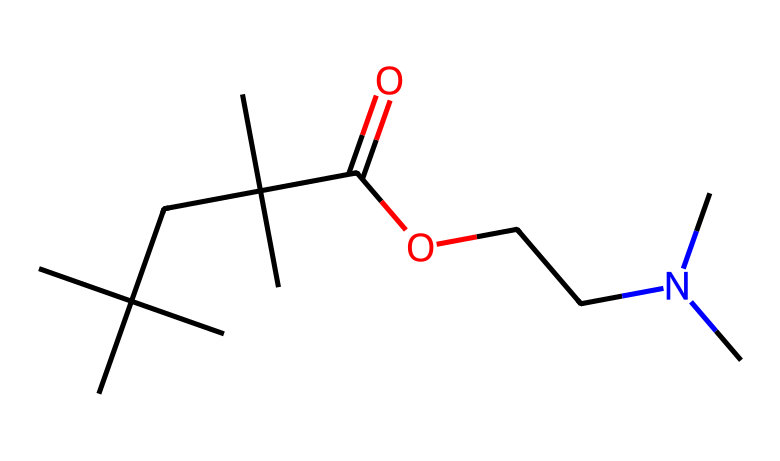What is the functional group present in this chemical? The chemical structure contains a carboxylic acid functional group, indicated by the -COOH moiety. The presence of the carbonyl (C=O) and hydroxy (O-H) groups confirms this.
Answer: carboxylic acid How many carbon atoms are in this molecule? By examining the structure, we can count a total of 14 carbon atoms present in the branched chain and the functional groups.
Answer: 14 What type of nitrogen compound is present in this molecule? The presence of the nitrogen atom bonded to two carbon chains and having a lone pair suggests it's a tertiary amine, which is defined by having three carbon substituents attached to the nitrogen.
Answer: tertiary amine What is the total number of double bonds in this molecule? Analyzing the structure reveals only one double bond, which is the carbonyl (C=O) of the carboxylic acid functional group.
Answer: 1 Which segment of the chemical contributes to its potential as a rust inhibitor? The carbon chain and functional groups such as the carboxylic acid are essential for forming protective layers on metal surfaces, thus contributing to anti-corrosive properties.
Answer: carbon chain and carboxylic acid Is this compound likely to be hydrophilic or hydrophobic? The presence of the carboxylic acid group suggests that the compound will be more hydrophilic due to its ability to form hydrogen bonds with water molecules.
Answer: hydrophilic 